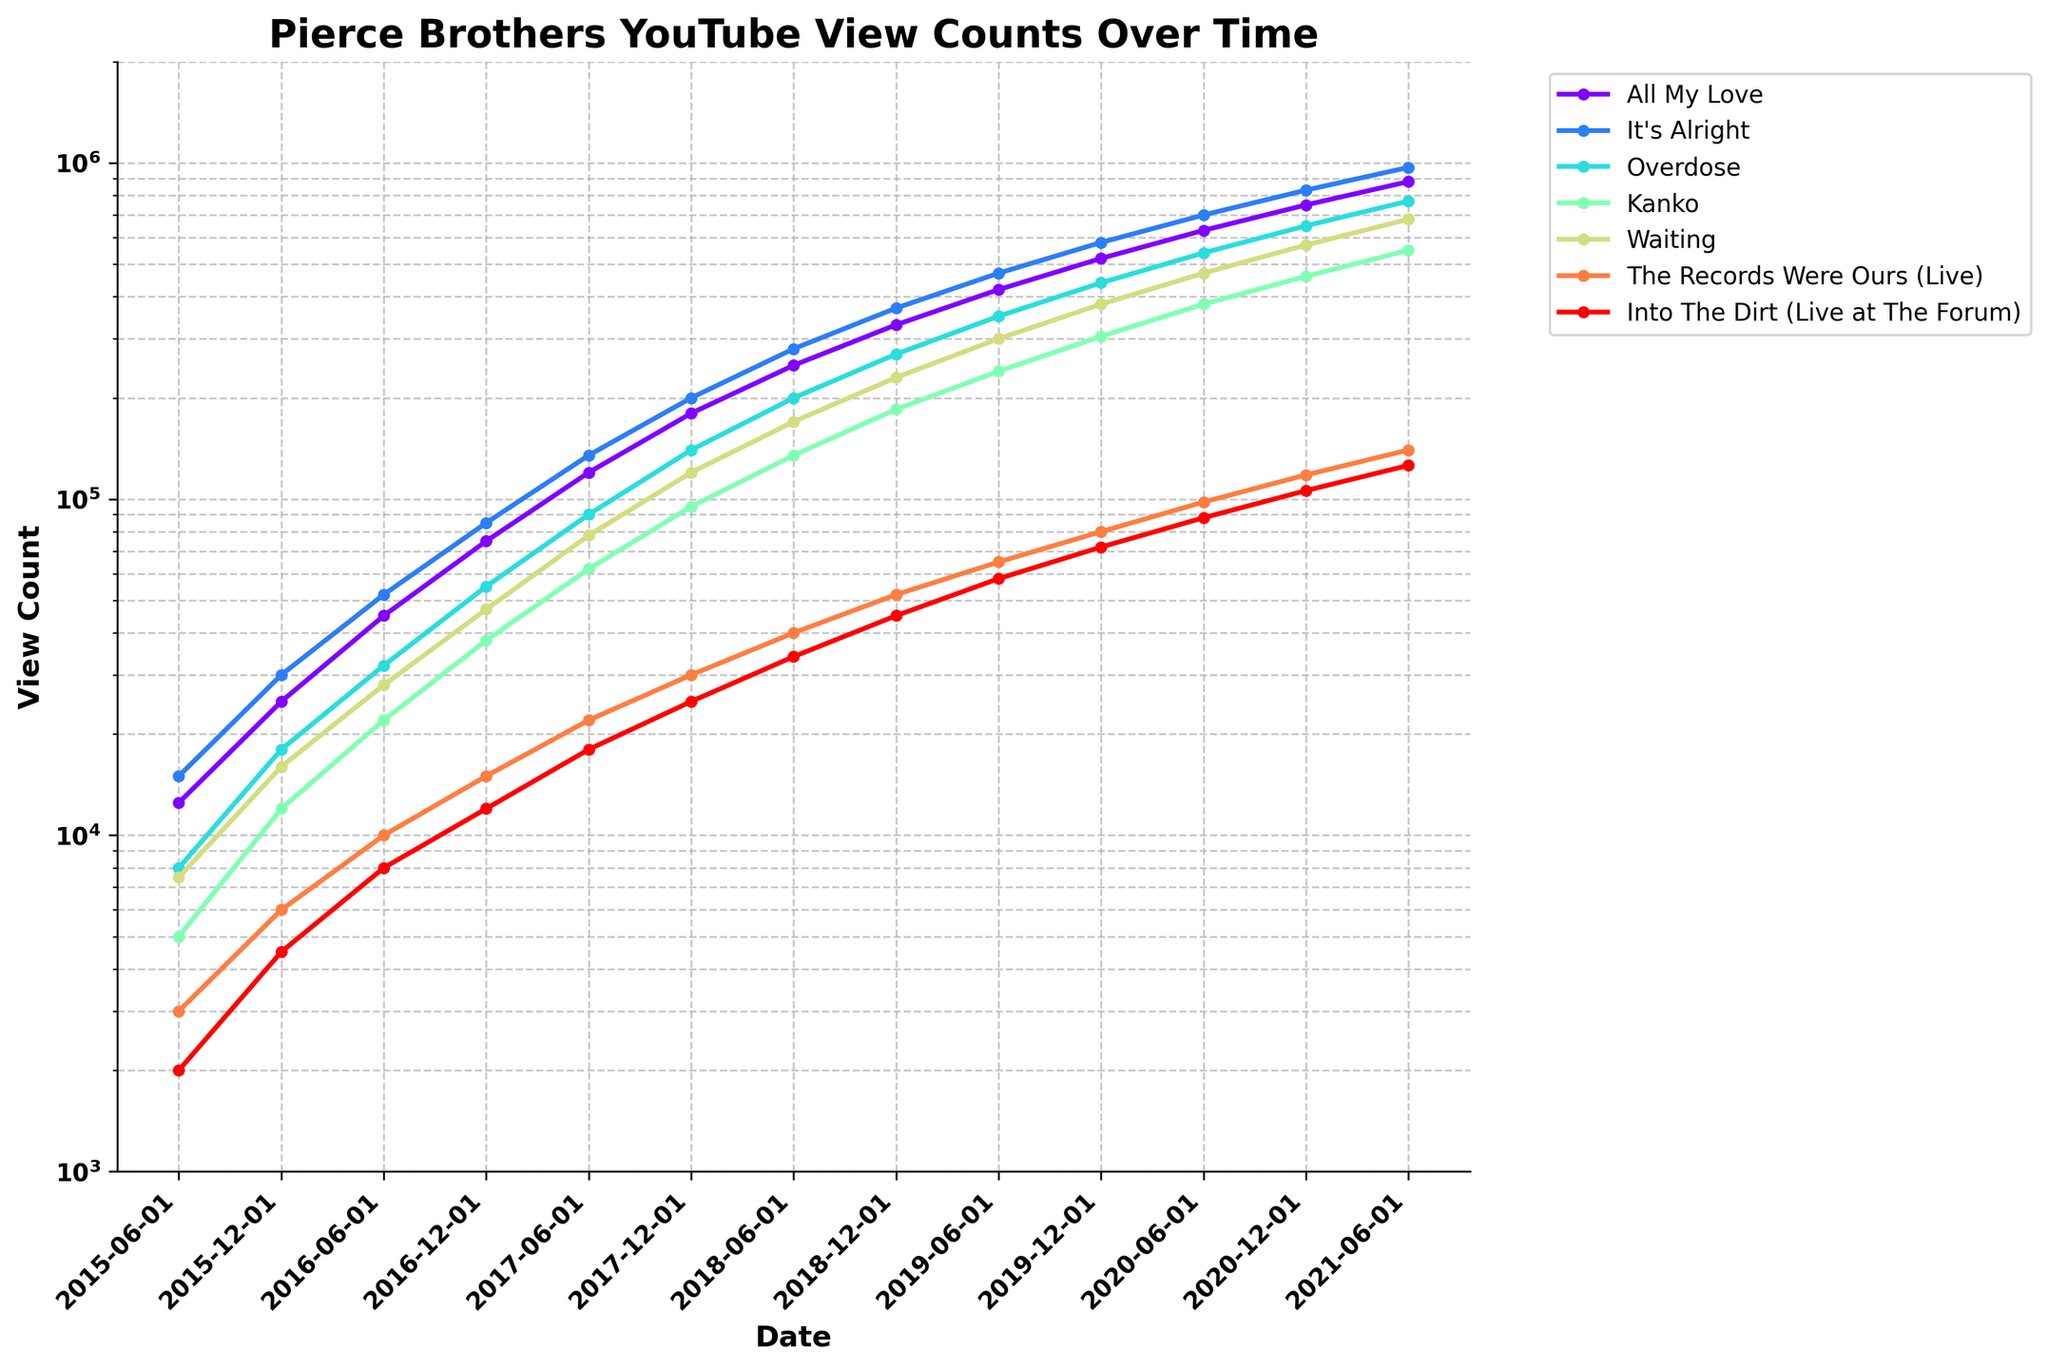What is the total view count for "All My Love" and "It's Alright" in June 2017? First, find the view counts for "All My Love" and "It's Alright" in June 2017. "All My Love" has 120,000 views, and "It's Alright" has 135,000 views. Sum these values: 120,000 + 135,000.
Answer: 255,000 Which video had the highest views in December 2020? Check the view counts for all videos in December 2020. "It's Alright" had 830,000 views, which is the highest.
Answer: It's Alright Between December 2017 and June 2018, which video had the largest increase in views? Calculate the difference in view counts between December 2017 and June 2018 for all videos. "All My Love" increased from 180,000 to 250,000 (70,000), "It's Alright" from 200,000 to 280,000 (80,000), "Overdose" from 140,000 to 200,000 (60,000), "Kanko" from 95,000 to 135,000 (40,000), "Waiting" from 120,000 to 170,000 (50,000), "The Records Were Ours (Live)" from 30,000 to 40,000 (10,000), and "Into The Dirt (Live at The Forum)" from 25,000 to 34,000 (9,000). "It's Alright" has the largest increase (80,000).
Answer: It's Alright What is the ratio of views for "Waiting" to "Kanko" in June 2019? Find the view counts for "Waiting" and "Kanko" in June 2019. "Waiting" has 300,000 views, and "Kanko" has 240,000 views. Calculate the ratio: 300,000 / 240,000 = 1.25.
Answer: 1.25 Which video showed the least growth from June 2015 to June 2016? Calculate the growth for each video from June 2015 to June 2016: "All My Love" (45,000 - 12,500) = 32,500, "It's Alright" (52,000 - 15,000) = 37,000, "Overdose" (32,000 - 8,000) = 24,000, "Kanko" (22,000 - 5,000) = 17,000, "Waiting" (28,000 - 7,500) = 20,500, "The Records Were Ours (Live)" (10,000 - 3,000) = 7,000, and "Into The Dirt (Live at The Forum)" (8,000 - 2,000) = 6,000. "Into The Dirt (Live at The Forum)" showed the least growth (6,000).
Answer: Into The Dirt (Live at The Forum) Which video had approximately equal views in June 2020 and December 2020? Compare the views for each video in June 2020 and December 2020. "Into The Dirt (Live at The Forum)" had views of 88,000 in June 2020 and 106,000 in December 2020, which are relatively close.
Answer: Into The Dirt (Live at The Forum) What is the average view count for "All My Love" in December over the years provided? Find the view counts for "All My Love" in every December: 2015 - 25,000, 2016 - 75,000, 2017 - 180,000, 2018 - 330,000, 2019 - 520,000, 2020 - 750,000. Sum these values: 25,000 + 75,000 + 180,000 + 330,000 + 520,000 + 750,000 = 1,880,000. Divide by 6 (number of years): 1,880,000 / 6.
Answer: 313,333 From June 2020 to June 2021, which live performance had the higher percentage increase in views? Calculate the percentage increase for each live performance: "The Records Were Ours (Live)" [(140,000 - 98,000) / 98,000] * 100 = 42.86%, "Into The Dirt (Live at The Forum)" [(126,000 - 88,000) / 88,000] * 100 = 43.18%. "Into The Dirt (Live at The Forum)" had the higher percentage increase.
Answer: Into The Dirt (Live at The Forum) 